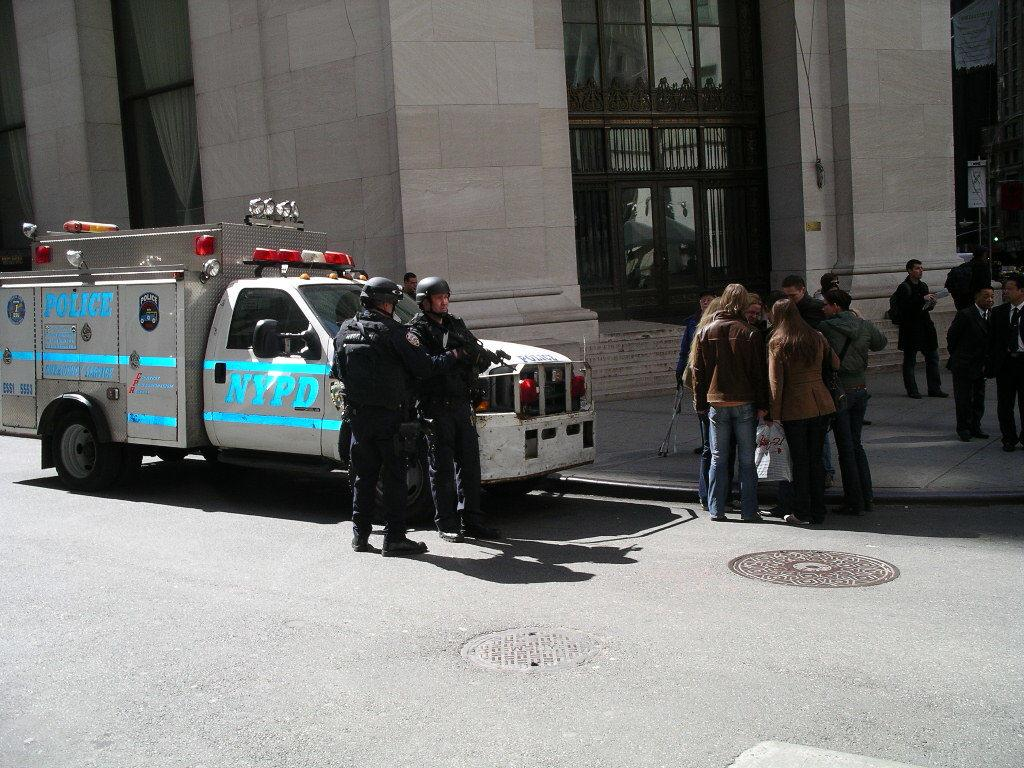What is the main subject of the image? The main subject of the image is a vehicle. Are there any people present in the image? Yes, there are people in the image. Can you describe the attire of some of the people? Two persons are wearing helmets. What type of building can be seen in the image? There is a building with glass walls in the image. How many geese are swimming in the liquid in the image? There are no geese or liquid present in the image. What is the cause of the building's glass walls in the image? The cause of the building's glass walls is not mentioned in the image or the provided facts. 